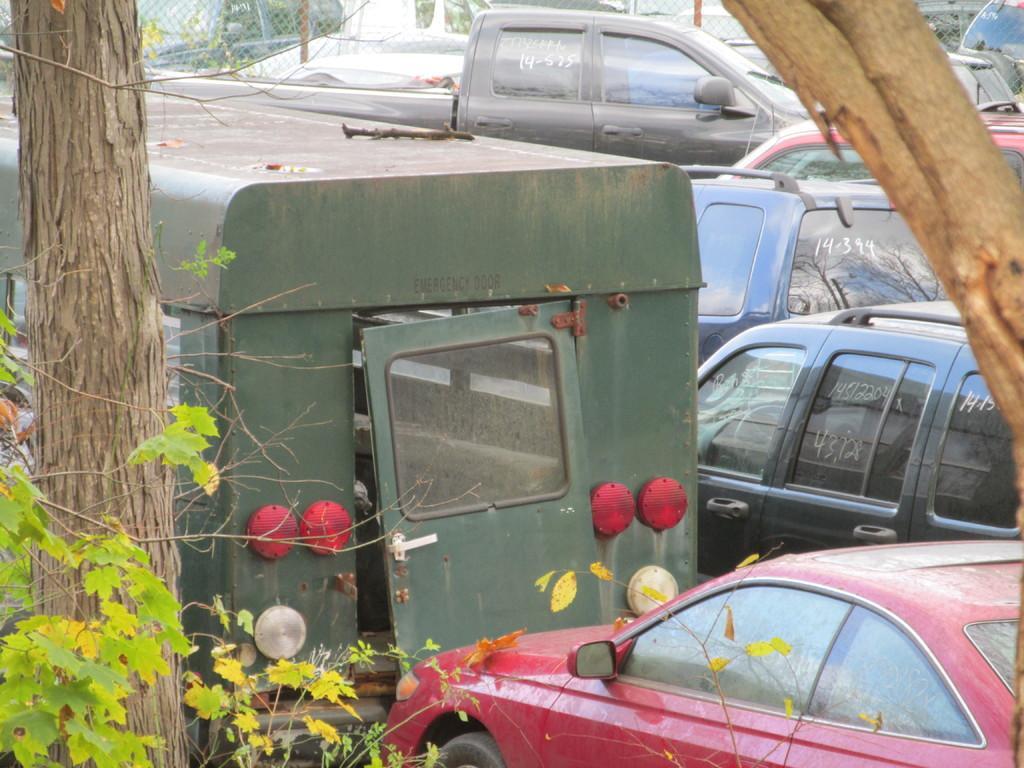Describe this image in one or two sentences. In this picture we can see a few vehicles from left to right. There is a plant and a tree trunk on the left side. We can see a wooden object on the right side. There is some fencing visible in the background. 